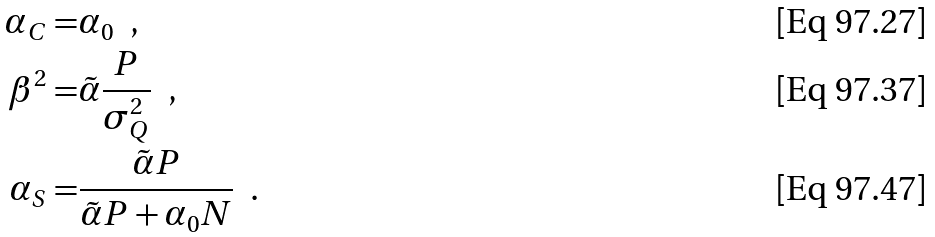Convert formula to latex. <formula><loc_0><loc_0><loc_500><loc_500>\alpha _ { C } = & \alpha _ { 0 } \ \ , \\ \beta ^ { 2 } = & \tilde { \alpha } \frac { P } { \sigma _ { Q } ^ { 2 } } \ \ , \\ \alpha _ { S } = & \frac { \tilde { \alpha } P } { \tilde { \alpha } P + \alpha _ { 0 } N } \ \ .</formula> 